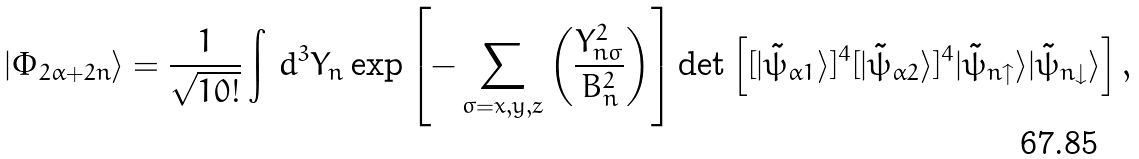Convert formula to latex. <formula><loc_0><loc_0><loc_500><loc_500>| \Phi _ { 2 \alpha + 2 n } \rangle = \frac { 1 } { \sqrt { 1 0 ! } } \int & \ d ^ { 3 } Y _ { n } \exp \left [ - \sum _ { \sigma = x , y , z } \left ( \frac { Y _ { n \sigma } ^ { 2 } } { B _ { n } ^ { 2 } } \right ) \right ] \det \left [ [ | \tilde { \psi } _ { \alpha 1 } \rangle ] ^ { 4 } [ | \tilde { \psi } _ { \alpha 2 } \rangle ] ^ { 4 } | \tilde { \psi } _ { n \uparrow } \rangle | \tilde { \psi } _ { n \downarrow } \rangle \right ] ,</formula> 